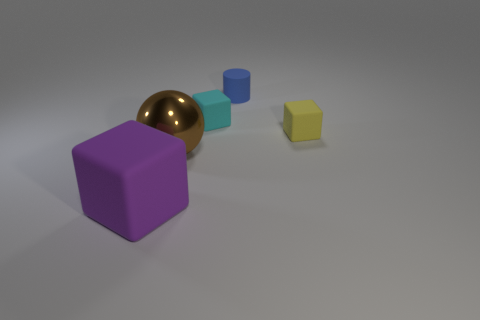There is a yellow thing that is the same shape as the small cyan object; what size is it? small 